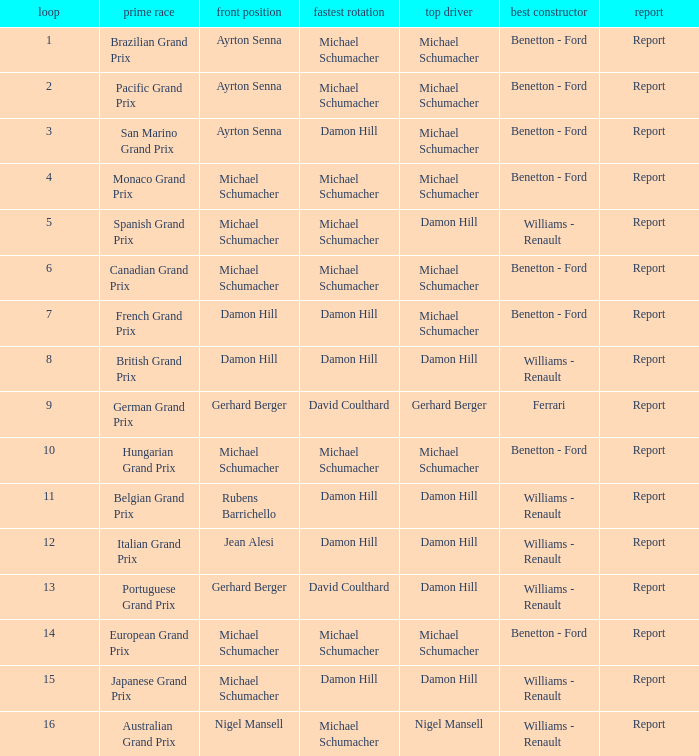Parse the full table. {'header': ['loop', 'prime race', 'front position', 'fastest rotation', 'top driver', 'best constructor', 'report'], 'rows': [['1', 'Brazilian Grand Prix', 'Ayrton Senna', 'Michael Schumacher', 'Michael Schumacher', 'Benetton - Ford', 'Report'], ['2', 'Pacific Grand Prix', 'Ayrton Senna', 'Michael Schumacher', 'Michael Schumacher', 'Benetton - Ford', 'Report'], ['3', 'San Marino Grand Prix', 'Ayrton Senna', 'Damon Hill', 'Michael Schumacher', 'Benetton - Ford', 'Report'], ['4', 'Monaco Grand Prix', 'Michael Schumacher', 'Michael Schumacher', 'Michael Schumacher', 'Benetton - Ford', 'Report'], ['5', 'Spanish Grand Prix', 'Michael Schumacher', 'Michael Schumacher', 'Damon Hill', 'Williams - Renault', 'Report'], ['6', 'Canadian Grand Prix', 'Michael Schumacher', 'Michael Schumacher', 'Michael Schumacher', 'Benetton - Ford', 'Report'], ['7', 'French Grand Prix', 'Damon Hill', 'Damon Hill', 'Michael Schumacher', 'Benetton - Ford', 'Report'], ['8', 'British Grand Prix', 'Damon Hill', 'Damon Hill', 'Damon Hill', 'Williams - Renault', 'Report'], ['9', 'German Grand Prix', 'Gerhard Berger', 'David Coulthard', 'Gerhard Berger', 'Ferrari', 'Report'], ['10', 'Hungarian Grand Prix', 'Michael Schumacher', 'Michael Schumacher', 'Michael Schumacher', 'Benetton - Ford', 'Report'], ['11', 'Belgian Grand Prix', 'Rubens Barrichello', 'Damon Hill', 'Damon Hill', 'Williams - Renault', 'Report'], ['12', 'Italian Grand Prix', 'Jean Alesi', 'Damon Hill', 'Damon Hill', 'Williams - Renault', 'Report'], ['13', 'Portuguese Grand Prix', 'Gerhard Berger', 'David Coulthard', 'Damon Hill', 'Williams - Renault', 'Report'], ['14', 'European Grand Prix', 'Michael Schumacher', 'Michael Schumacher', 'Michael Schumacher', 'Benetton - Ford', 'Report'], ['15', 'Japanese Grand Prix', 'Michael Schumacher', 'Damon Hill', 'Damon Hill', 'Williams - Renault', 'Report'], ['16', 'Australian Grand Prix', 'Nigel Mansell', 'Michael Schumacher', 'Nigel Mansell', 'Williams - Renault', 'Report']]} Name the pole position at the japanese grand prix when the fastest lap is damon hill Michael Schumacher. 